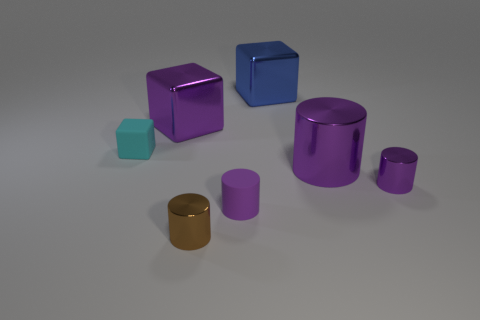Subtract all large cubes. How many cubes are left? 1 Subtract all blue spheres. How many purple cylinders are left? 3 Subtract all brown cylinders. How many cylinders are left? 3 Add 1 big blue cubes. How many objects exist? 8 Subtract all blue cylinders. Subtract all cyan cubes. How many cylinders are left? 4 Subtract all cylinders. How many objects are left? 3 Add 4 metal things. How many metal things are left? 9 Add 3 purple metallic blocks. How many purple metallic blocks exist? 4 Subtract 0 red spheres. How many objects are left? 7 Subtract all cyan matte blocks. Subtract all large yellow rubber cylinders. How many objects are left? 6 